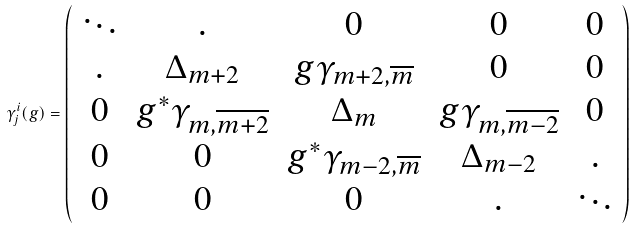<formula> <loc_0><loc_0><loc_500><loc_500>\gamma ^ { i } _ { j } ( g ) = \left ( \begin{array} { c c c c c } \ddots & . & 0 & 0 & 0 \\ . & \Delta _ { m + 2 } & g \gamma _ { m + 2 , \overline { m } } & 0 & 0 \\ 0 & g ^ { * } \gamma _ { m , \overline { m + 2 } } & \Delta _ { m } & g \gamma _ { m , \overline { m - 2 } } & 0 \\ 0 & 0 & g ^ { * } \gamma _ { m - 2 , \overline { m } } & \Delta _ { m - 2 } & . \\ 0 & 0 & 0 & . & \ddots \end{array} \right )</formula> 